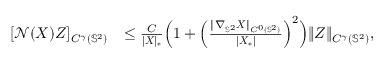<formula> <loc_0><loc_0><loc_500><loc_500>\begin{array} { r l } { [ \mathcal { N } ( X ) Z ] _ { C ^ { \gamma } ( \mathbb { S } ^ { 2 } ) } } & { \leq \frac { C } { | X | _ { * } } \left ( 1 + \left ( \frac { \| \nabla _ { \mathbb { S } ^ { 2 } } X \| _ { C ^ { 0 } ( \mathbb { S } ^ { 2 } ) } } { | X _ { * } | } \right ) ^ { 2 } \right ) \| Z \| _ { C ^ { \gamma } ( \mathbb { S } ^ { 2 } ) } , } \end{array}</formula> 